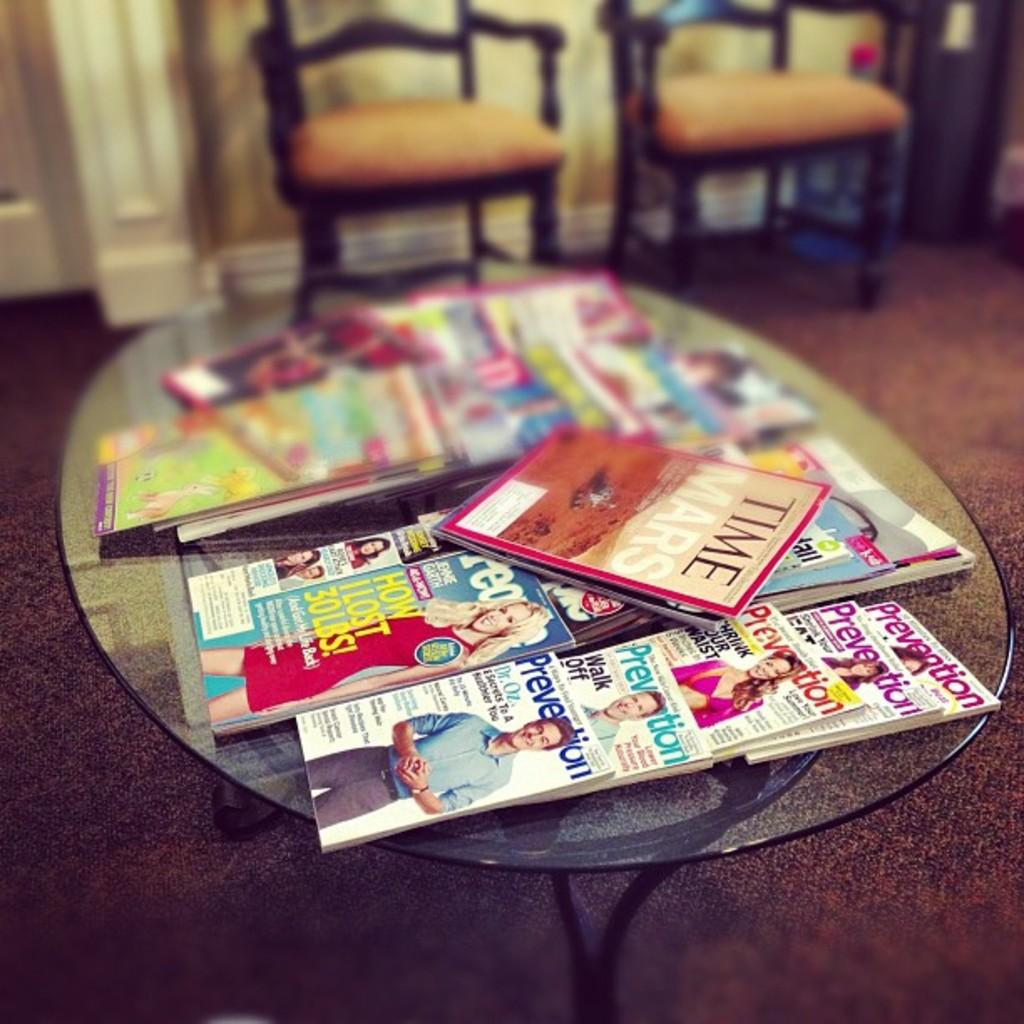What type of furniture is present in the image? There is a table in the image. What items can be seen on the table? There are books and other objects on the table. What can be seen in the background of the image? There are chairs, a wall, and other objects in the background of the image. What part of the room is visible at the bottom of the image? The floor is visible at the bottom of the image. What type of pollution is visible in the image? There is no pollution visible in the image; it features a table with books and other objects, chairs, a wall, and the floor. 